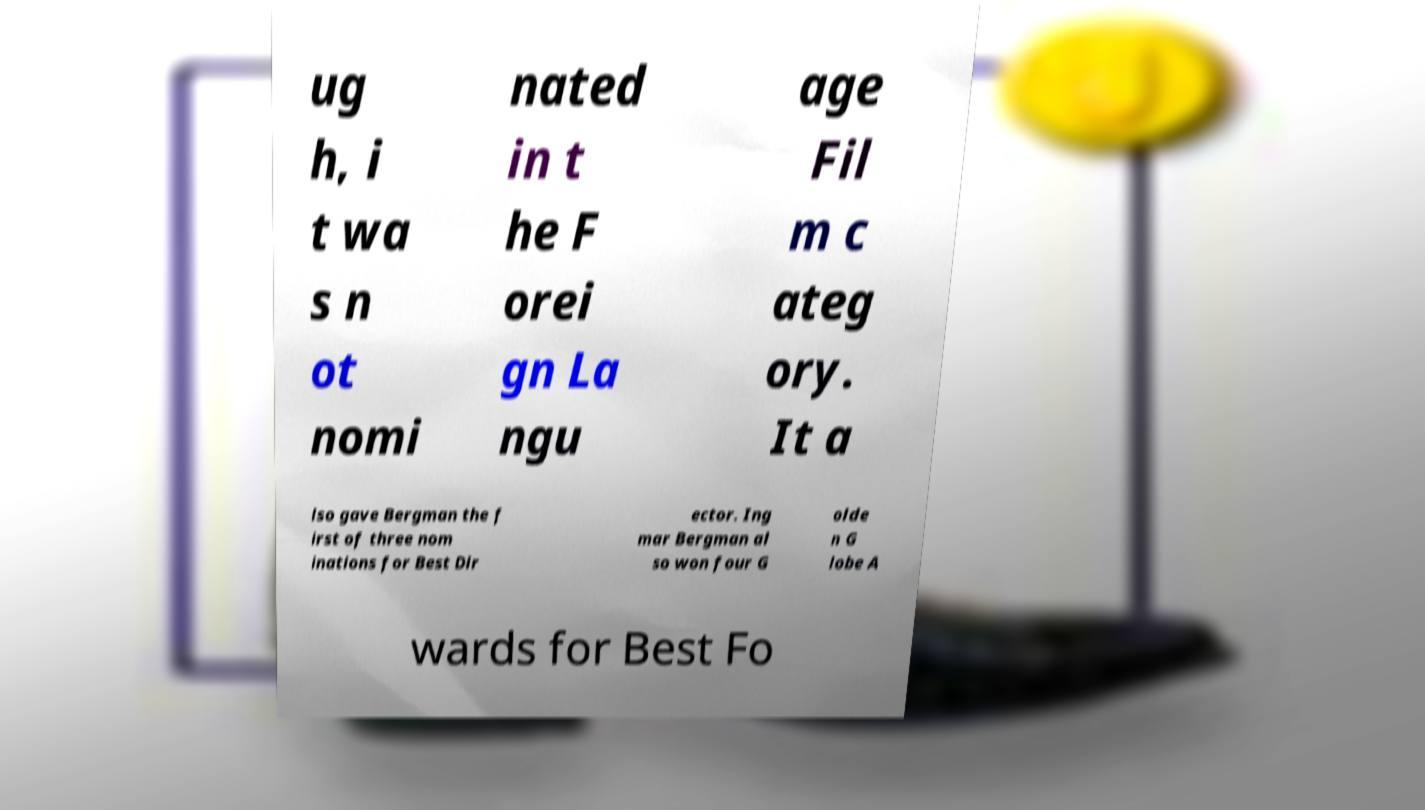I need the written content from this picture converted into text. Can you do that? ug h, i t wa s n ot nomi nated in t he F orei gn La ngu age Fil m c ateg ory. It a lso gave Bergman the f irst of three nom inations for Best Dir ector. Ing mar Bergman al so won four G olde n G lobe A wards for Best Fo 